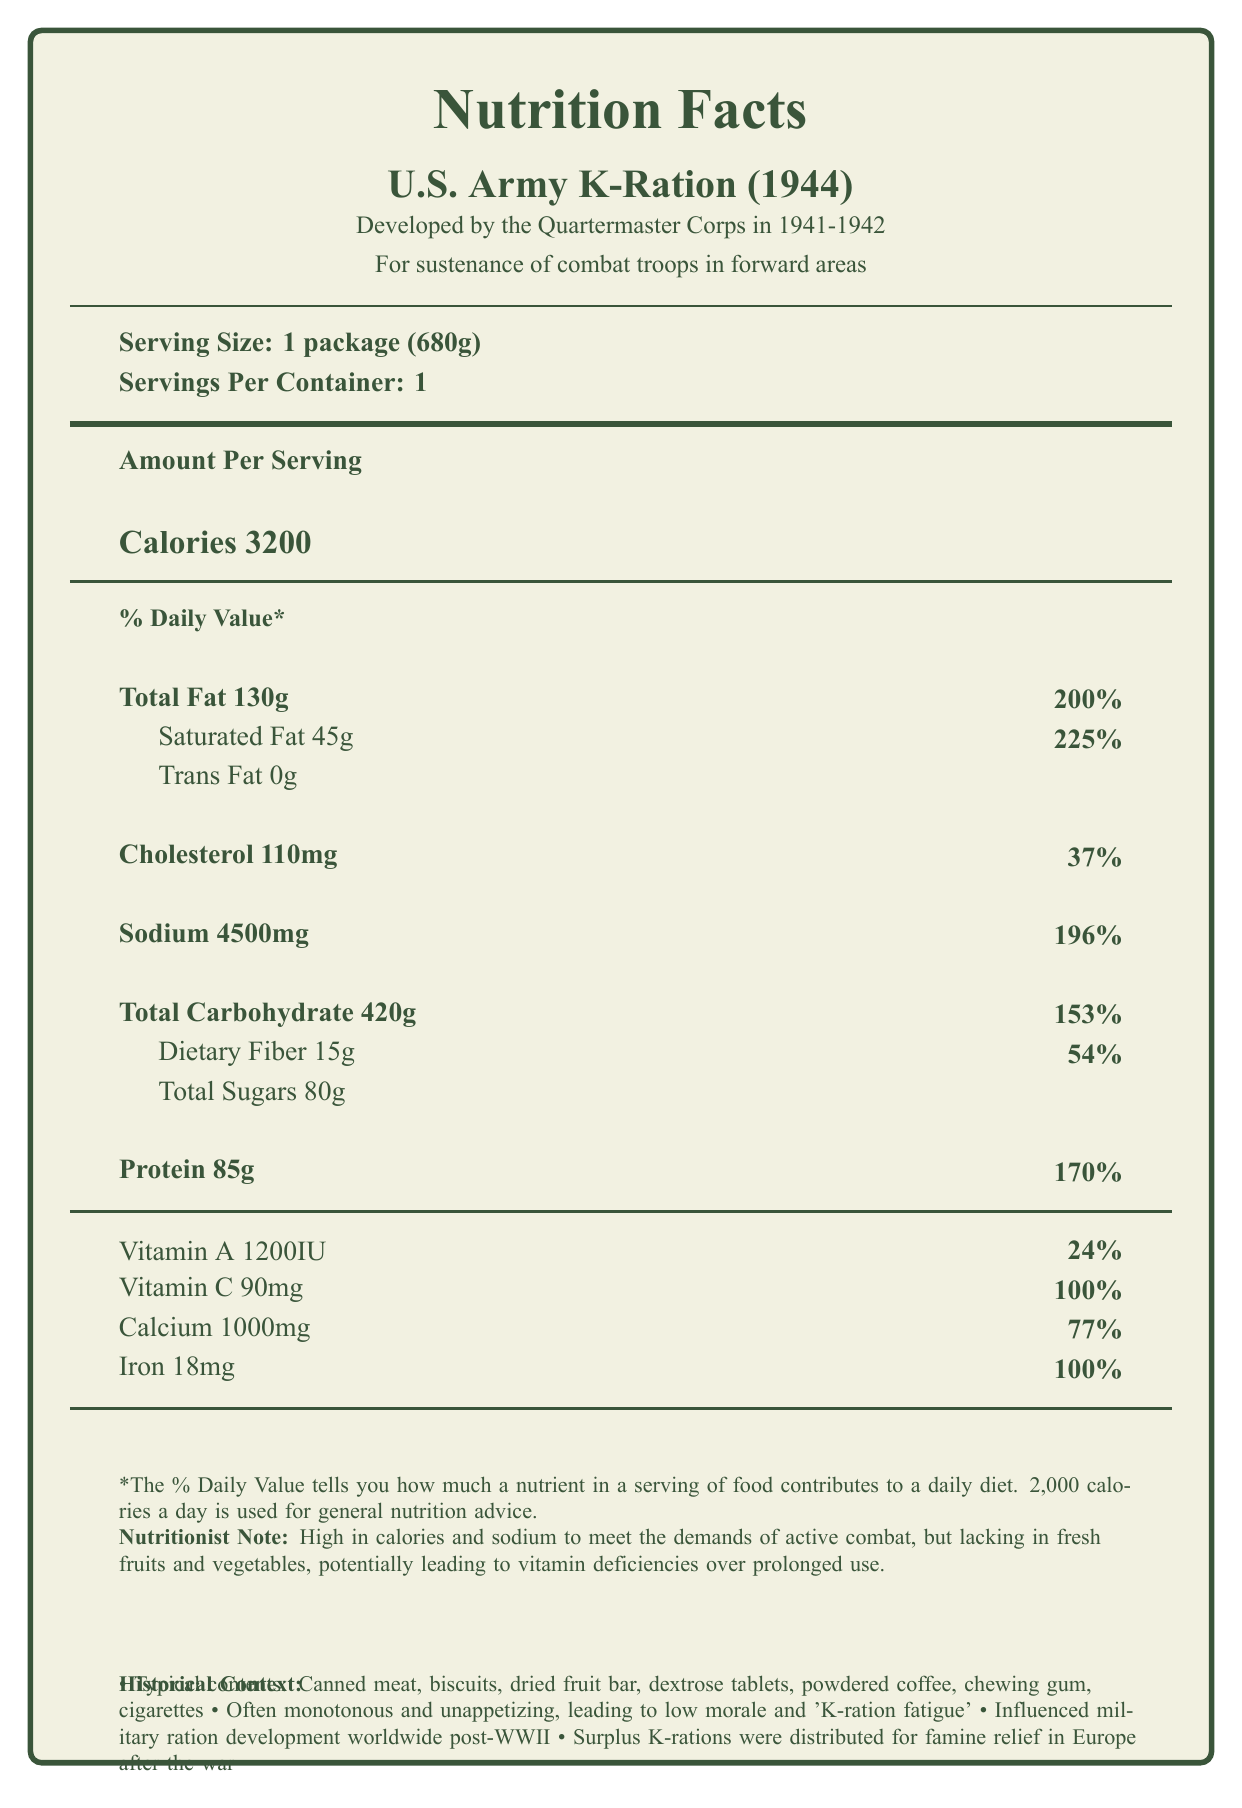What is the serving size for the U.S. Army K-Ration (1944)? The serving size is clearly stated in the document as 1 package (680g).
Answer: 1 package (680g) How many calories are in one serving of the U.S. Army K-Ration (1944)? The document lists the calories per serving as 3200.
Answer: 3200 What percentage of the daily value of protein does the U.S. Army K-Ration provide? The document states that the protein content is 85g, which is 170% of the daily value.
Answer: 170% How much sodium does one serving of the K-Ration contain? The document specifies that there are 4500mg of sodium per serving.
Answer: 4500mg What are the typical contents found in the U.S. Army K-Ration (1944)? The document lists these items under "typical contents."
Answer: Canned meat, biscuits, dried fruit bar, dextrose tablets, powdered coffee, chewing gum, cigarettes Which of the following nutrients is NOT found in the U.S. Army K-Ration? A. Vitamin A B. Vitamin D C. Vitamin C D. Calcium Vitamin D is not listed in the document, whereas Vitamin A, Vitamin C, and Calcium are mentioned.
Answer: B What was one major impact of the U.S. Army K-Ration on global military ration development post-WWII? A. Increased use of fresh fruits B. Improved morale among soldiers C. Influenced military ration development worldwide D. Decreased sodium levels The document states that the K-Ration "influenced military ration development worldwide post-WWII."
Answer: C How many grams of total carbohydrates does the U.S. Army K-Ration contain? The total carbohydrate content is listed as 420g.
Answer: 420g Does the K-Ration contain trans fats? The document indicates that the amount of trans fat is 0g.
Answer: No Summarize the nutritional profile and historical context of the U.S. Army K-Ration (1944). The document provides detailed nutrition facts, including calorie count, fat, protein, carbohydrate content, and more. It also offers historical context, describing its development, purpose, contents, and impact.
Answer: The U.S. Army K-Ration (1944) was developed by the Quartermaster Corps to provide a day's sustenance for combat troops. It contains high calories (3200) and high sodium (4500mg), aimed at meeting the demands of active combat. Typical contents included canned meat, biscuits, and dried fruit bars. However, it lacked fresh fruits and vegetables, which could lead to vitamin deficiencies. Post-WWII, it influenced global military ration development and was used for famine relief in Europe. What was a significant issue experienced by soldiers consuming the K-Ration? The document mentions that soldiers often found the food monotonous and unappetizing, which led to low morale and 'K-ration fatigue.'
Answer: Monotonous and unappetizing food leading to 'K-ration fatigue' To what military corps was the development of the U.S. Army K-Ration attributed? The document states that the K-Ration was developed by the Quartermaster Corps in 1941-1942.
Answer: Quartermaster Corps How much iron does one serving of the U.S. Army K-Ration contain? The iron content is listed as 18mg, which is 100% of the daily value.
Answer: 18mg Which component is NOT mentioned as a typical content of the K-Ration? A. Canned meat B. Chewing gum C. Fresh fruits D. Biscuits The document mentions canned meat, chewing gum, and biscuits but does not mention fresh fruits.
Answer: C Identify one consequence of the high sodium content in the K-Ration highlighted by the nutritionist note. The nutritionist note mentions that while the ration is high in calories and sodium to meet combat demands, it lacks fresh fruits and vegetables, potentially leading to vitamin deficiencies over prolonged use.
Answer: Potential vitamin deficiencies over prolonged use Did the U.S. Army K-Ration include sweets? The document mentions items like dried fruit bars and dextrose tablets, which are sweet.
Answer: Yes What is the overall main idea of the document? The document details the nutrition facts, historical development, components, typical contents, and the global impact of the K-Ration.
Answer: It provides the nutritional facts, historical context, components, and impact of the U.S. Army K-Ration (1944). How did surplus K-rations help civilians after the war? The document states that surplus K-rations were distributed for famine relief in Europe after the war.
Answer: They were distributed for famine relief in Europe. What was the purpose of the U.S. Army K-Ration (1944)? The document clearly states the purpose as providing a day's sustenance for combat troops in forward areas.
Answer: To provide a day's sustenance for combat troops in forward areas What were the three main meal units included in the K-Ration? According to the document, the K-Ration consisted of breakfast, dinner, and supper units.
Answer: Breakfast unit, Dinner unit, Supper unit What is the amount of Vitamin A provided by the K-Ration? The document lists the Vitamin A content as 1200 IU.
Answer: 1200 IU 